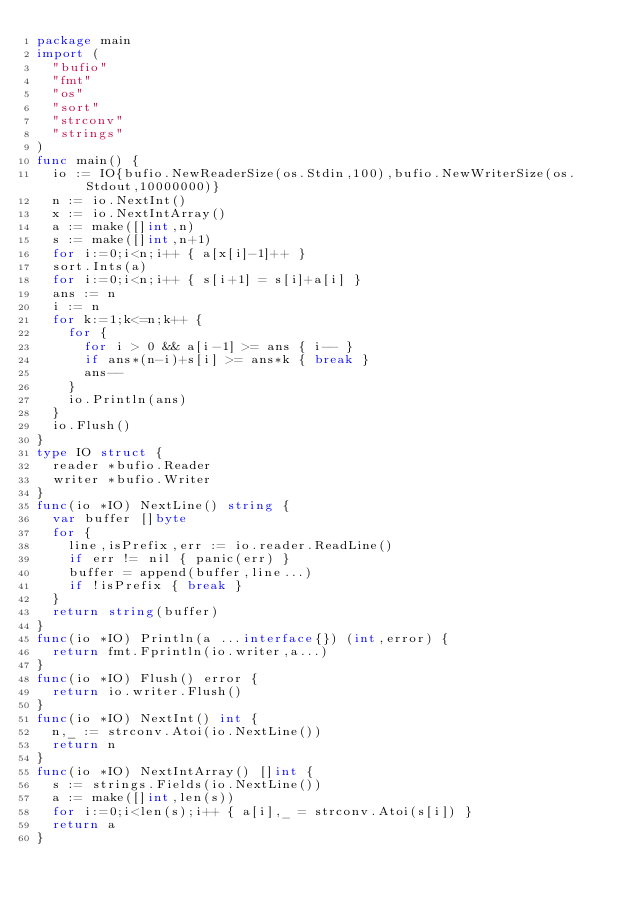<code> <loc_0><loc_0><loc_500><loc_500><_Go_>package main
import (
  "bufio"
  "fmt"
  "os"
  "sort"
  "strconv"
  "strings"
)
func main() {
  io := IO{bufio.NewReaderSize(os.Stdin,100),bufio.NewWriterSize(os.Stdout,10000000)}
  n := io.NextInt()
  x := io.NextIntArray()
  a := make([]int,n)
  s := make([]int,n+1)
  for i:=0;i<n;i++ { a[x[i]-1]++ }
  sort.Ints(a)
  for i:=0;i<n;i++ { s[i+1] = s[i]+a[i] }
  ans := n
  i := n
  for k:=1;k<=n;k++ {
    for {
      for i > 0 && a[i-1] >= ans { i-- }
      if ans*(n-i)+s[i] >= ans*k { break }
      ans--
    }
    io.Println(ans)
  }
  io.Flush()
}
type IO struct {
  reader *bufio.Reader
  writer *bufio.Writer
}
func(io *IO) NextLine() string {
  var buffer []byte
  for {
    line,isPrefix,err := io.reader.ReadLine()
    if err != nil { panic(err) }
    buffer = append(buffer,line...)
    if !isPrefix { break }
  }
  return string(buffer)
}
func(io *IO) Println(a ...interface{}) (int,error) {
  return fmt.Fprintln(io.writer,a...)
}
func(io *IO) Flush() error {
  return io.writer.Flush()
}
func(io *IO) NextInt() int {
  n,_ := strconv.Atoi(io.NextLine())
  return n
}
func(io *IO) NextIntArray() []int {
  s := strings.Fields(io.NextLine())
  a := make([]int,len(s))
  for i:=0;i<len(s);i++ { a[i],_ = strconv.Atoi(s[i]) }
  return a
}</code> 